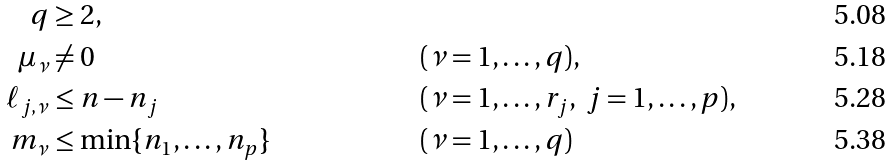<formula> <loc_0><loc_0><loc_500><loc_500>q & \geq 2 , \\ \mu _ { \nu } & \ne 0 & & ( \nu = 1 , \dots , q ) , \\ \ell _ { j , \nu } & \leq n - n _ { j } & & ( \nu = 1 , \dots , r _ { j } , \ j = 1 , \dots , p ) , \\ m _ { \nu } & \leq \min \{ n _ { 1 } , \dots , n _ { p } \} & & ( \nu = 1 , \dots , q )</formula> 